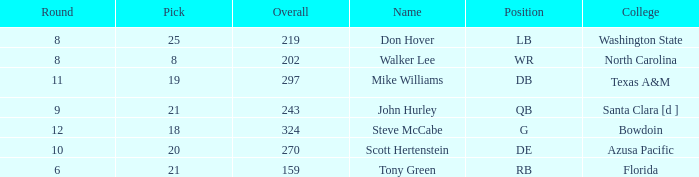Which college has a pick less than 25, an overall greater than 159, a round less than 10, and wr as the position? North Carolina. 